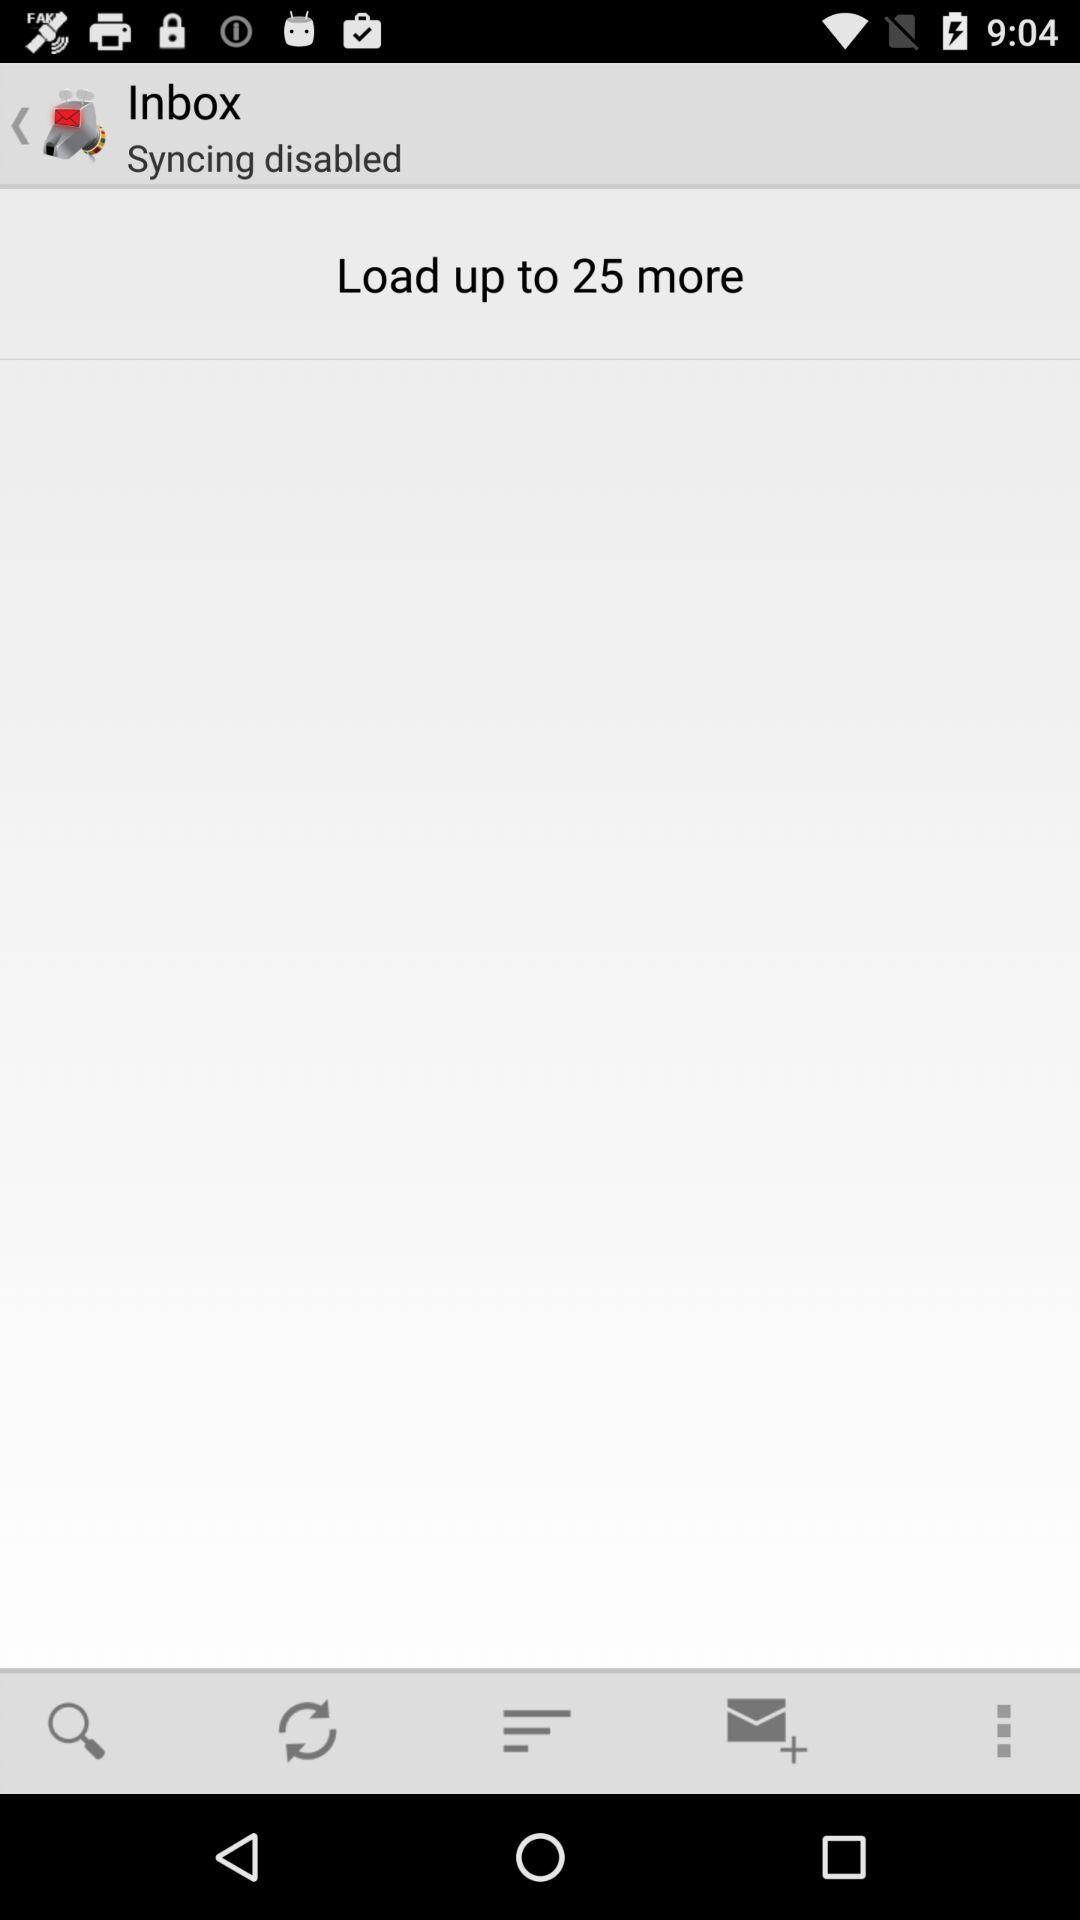How many more items can be loaded?
Answer the question using a single word or phrase. 25 